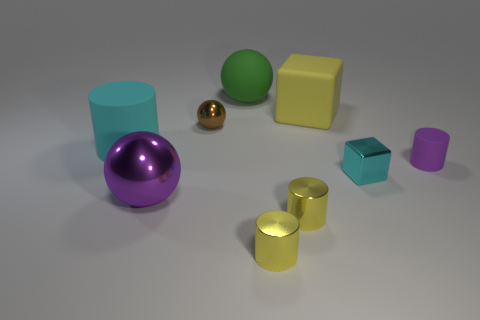There is a block that is made of the same material as the green ball; what color is it?
Your answer should be very brief. Yellow. Is there another rubber cube that has the same size as the yellow block?
Your answer should be very brief. No. What material is the big purple object that is the same shape as the tiny brown thing?
Provide a short and direct response. Metal. What shape is the cyan rubber thing that is the same size as the purple metallic ball?
Make the answer very short. Cylinder. Are there any blue things of the same shape as the brown metal object?
Offer a very short reply. No. What is the shape of the yellow thing that is behind the matte cylinder on the right side of the cyan rubber cylinder?
Your answer should be very brief. Cube. The green matte thing is what shape?
Ensure brevity in your answer.  Sphere. What is the cyan thing to the right of the tiny shiny thing behind the matte thing left of the big green matte object made of?
Provide a short and direct response. Metal. How many other things are there of the same material as the big green object?
Offer a terse response. 3. There is a big thing that is behind the big yellow thing; how many big objects are left of it?
Offer a terse response. 2. 